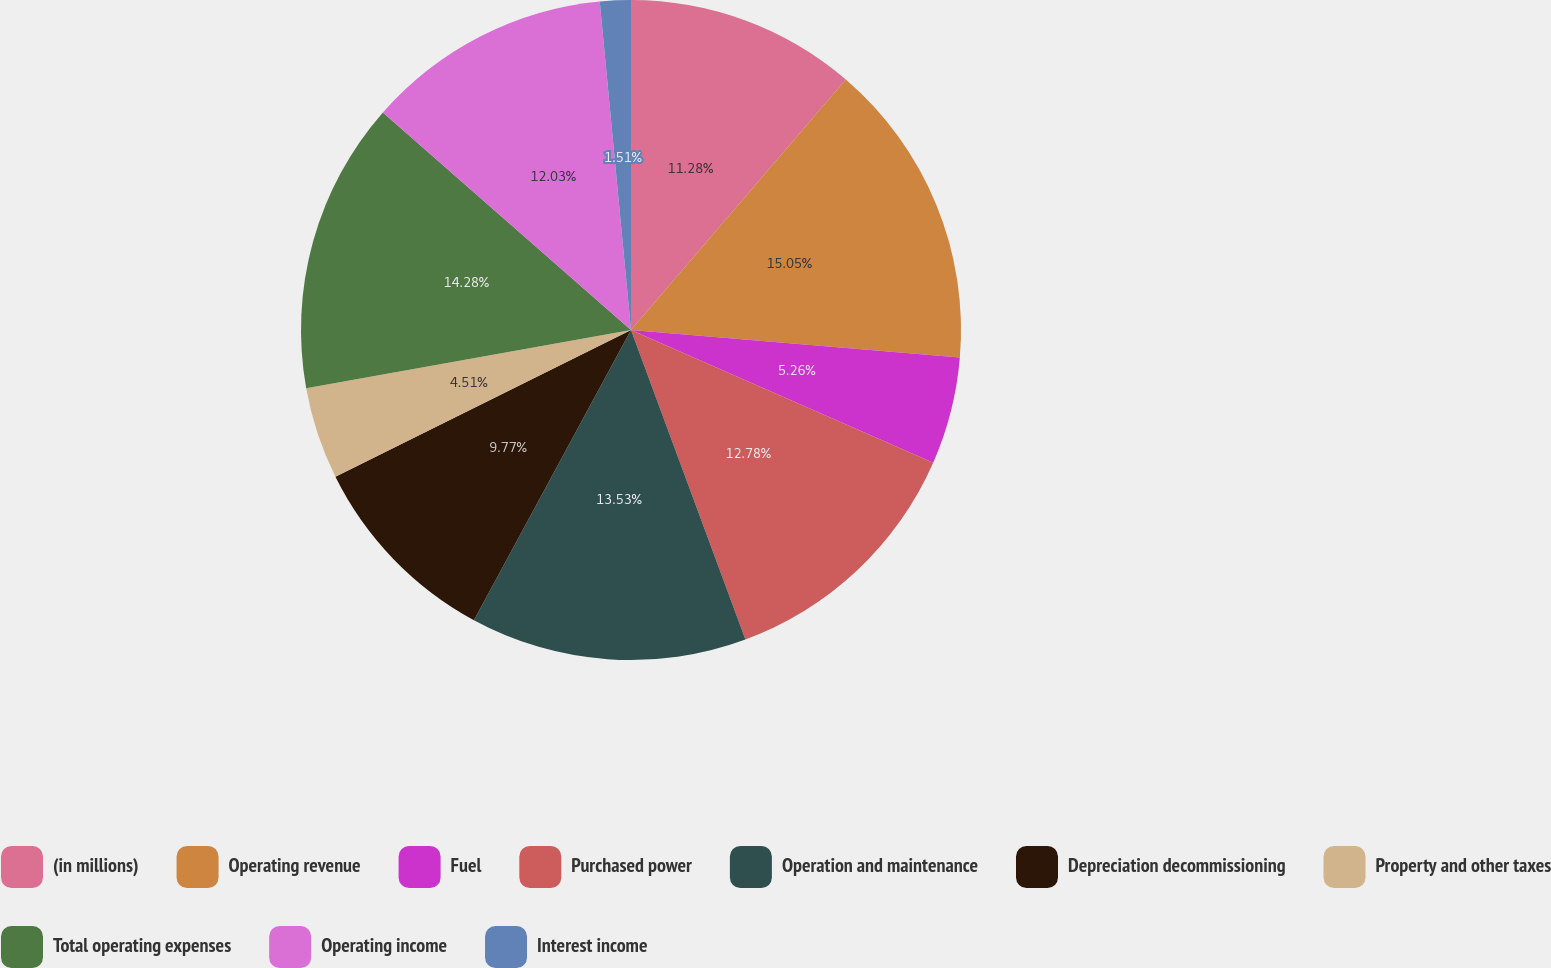Convert chart to OTSL. <chart><loc_0><loc_0><loc_500><loc_500><pie_chart><fcel>(in millions)<fcel>Operating revenue<fcel>Fuel<fcel>Purchased power<fcel>Operation and maintenance<fcel>Depreciation decommissioning<fcel>Property and other taxes<fcel>Total operating expenses<fcel>Operating income<fcel>Interest income<nl><fcel>11.28%<fcel>15.04%<fcel>5.26%<fcel>12.78%<fcel>13.53%<fcel>9.77%<fcel>4.51%<fcel>14.28%<fcel>12.03%<fcel>1.51%<nl></chart> 